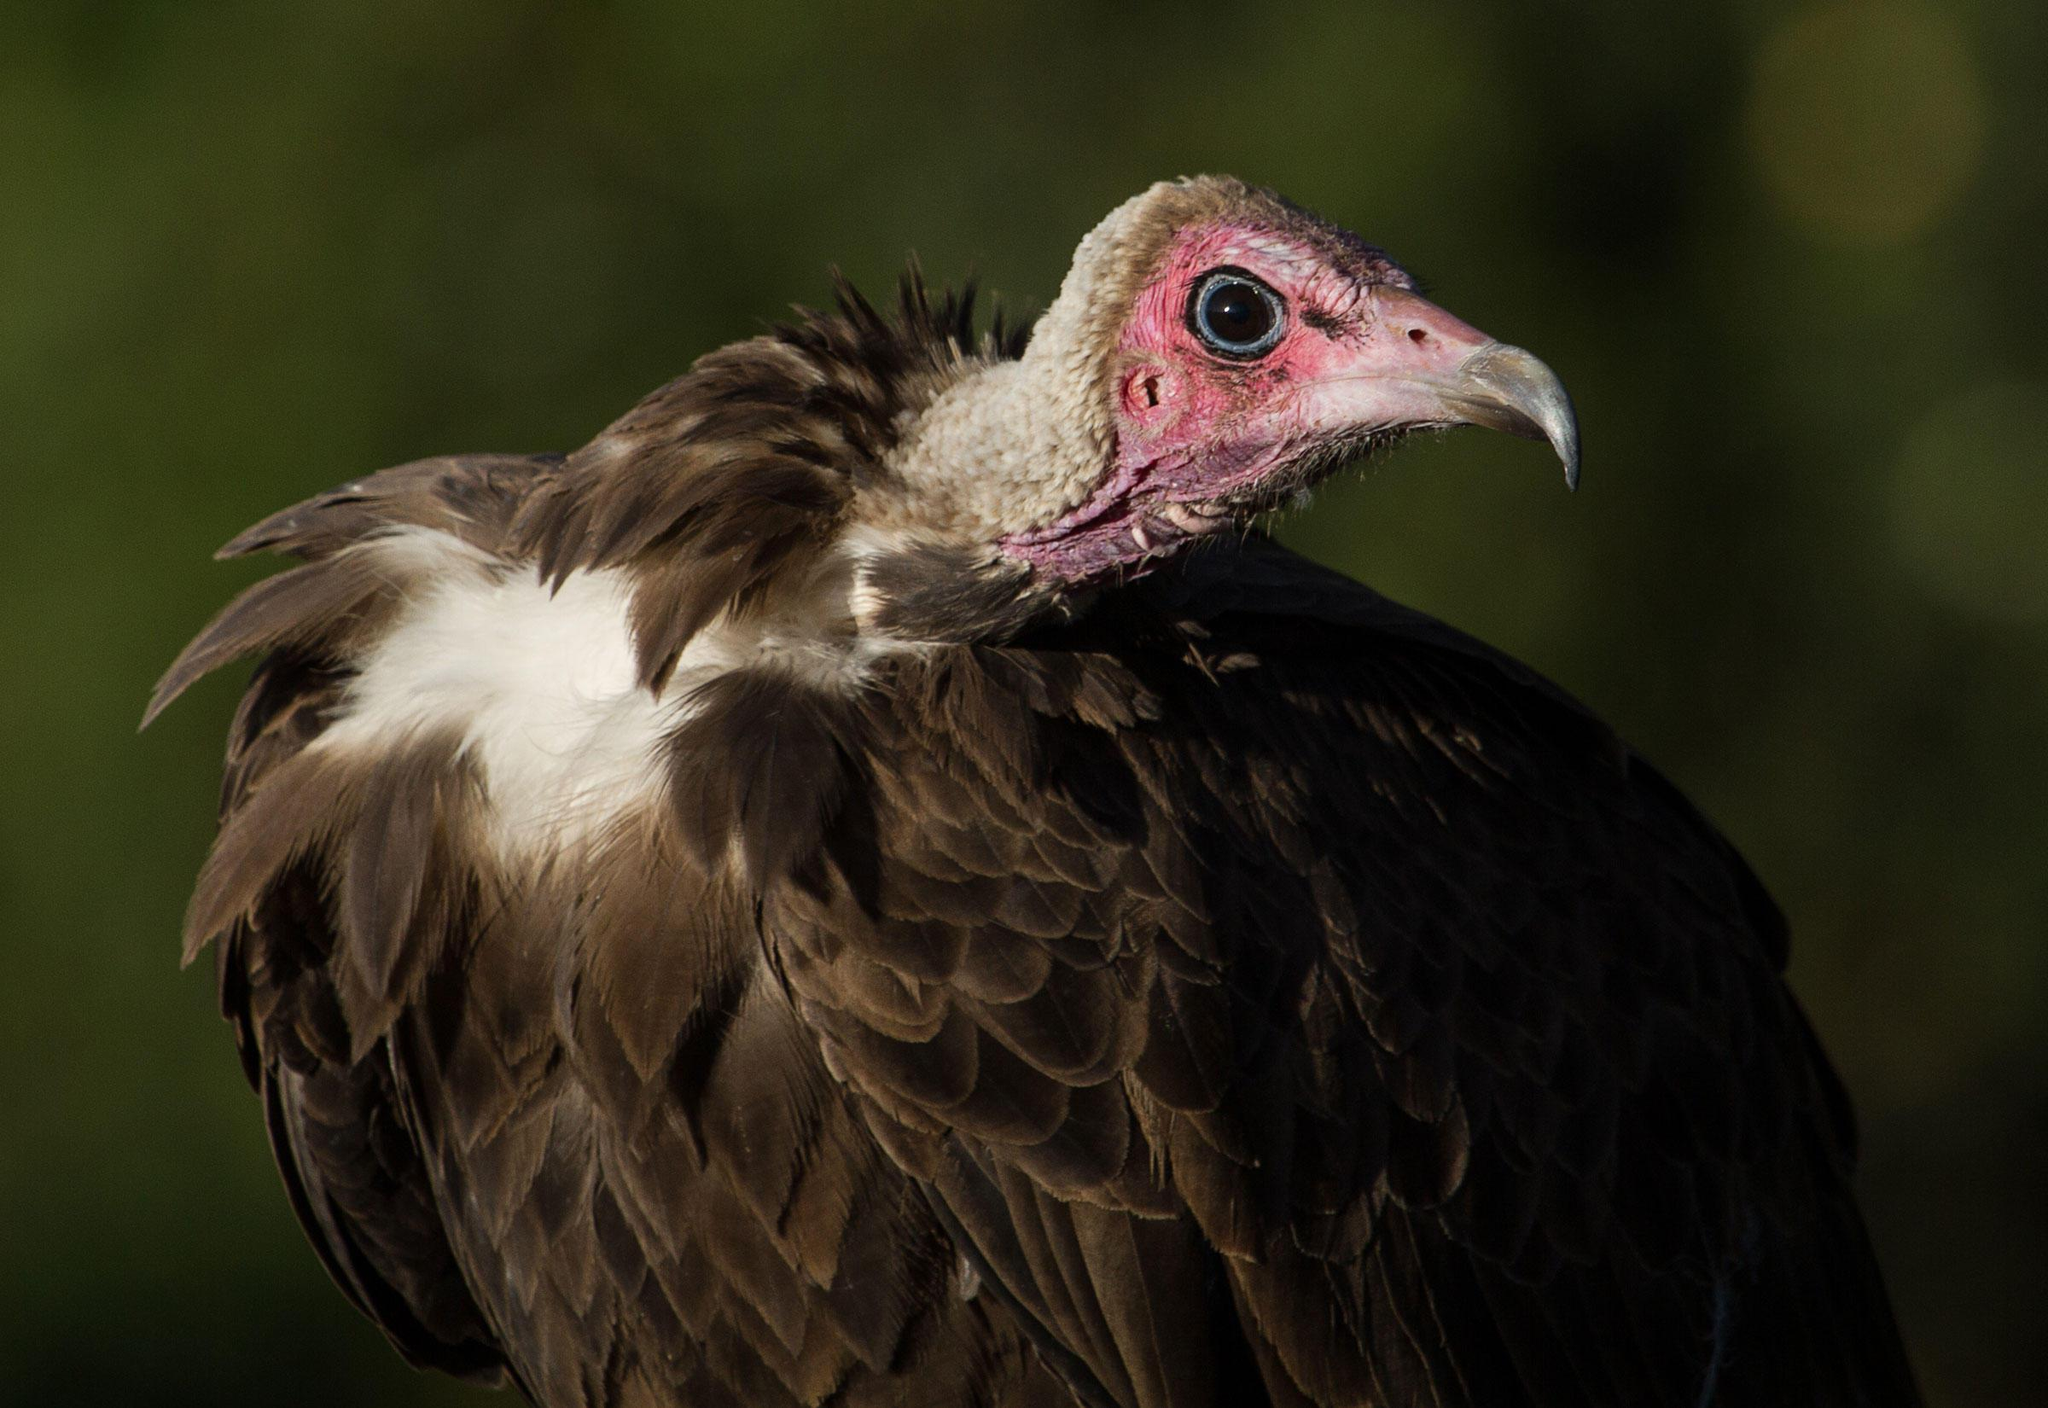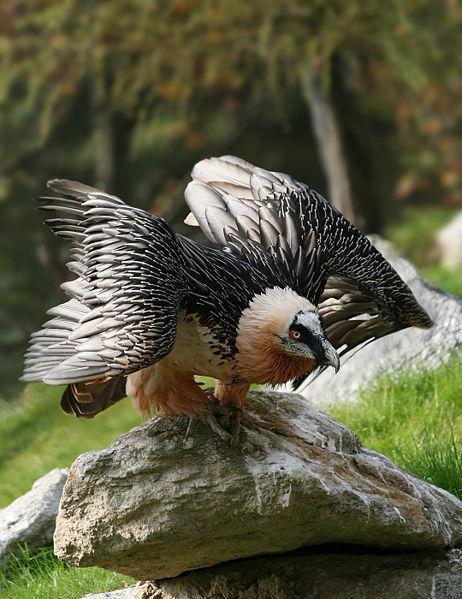The first image is the image on the left, the second image is the image on the right. Examine the images to the left and right. Is the description "A bird has a raised wing in one image." accurate? Answer yes or no. Yes. 